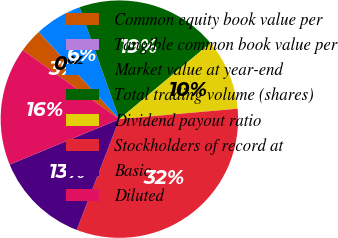<chart> <loc_0><loc_0><loc_500><loc_500><pie_chart><fcel>Common equity book value per<fcel>Tangible common book value per<fcel>Market value at year-end<fcel>Total trading volume (shares)<fcel>Dividend payout ratio<fcel>Stockholders of record at<fcel>Basic<fcel>Diluted<nl><fcel>3.23%<fcel>0.01%<fcel>6.45%<fcel>19.35%<fcel>9.68%<fcel>32.25%<fcel>12.9%<fcel>16.13%<nl></chart> 